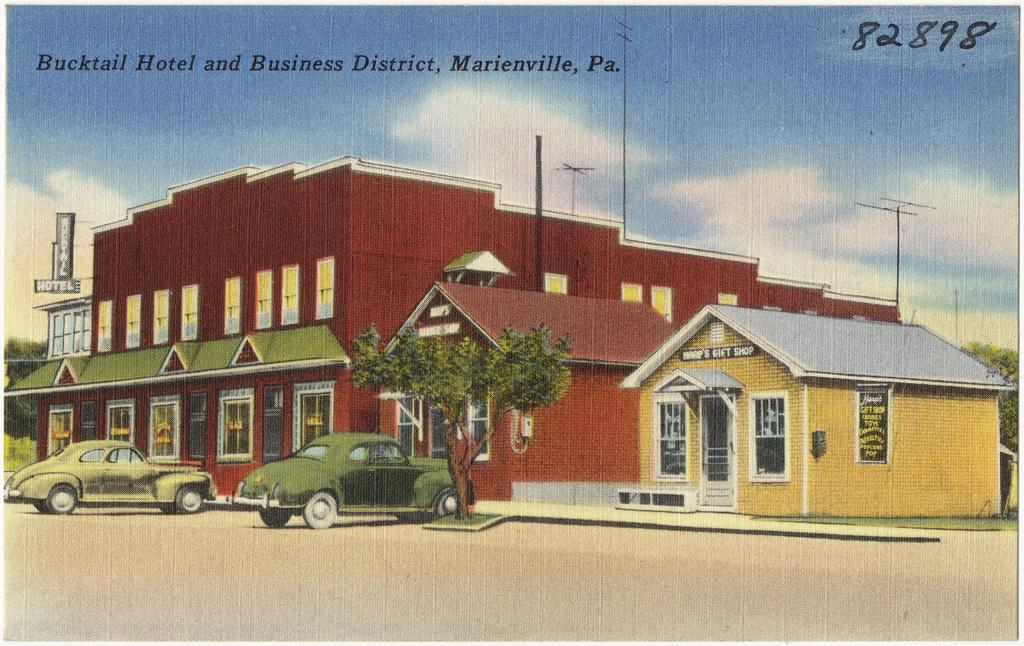What type of structure is visible in the image? There is a house and a building in the image. What mode of transportation can be seen in the image? Cars are depicted in the image. What is the medium of the image? The image is printed on paper. What type of vegetation is present in the image? There are trees and plants in the image. What can be seen in the sky in the image? There are clouds in the sky. What type of harmony is being played by the trees in the image? There is no indication of harmony being played by the trees in the image, as trees do not produce music. What type of shade is provided by the clouds in the image? The clouds in the image do not provide shade, as they are in the sky and not directly above any objects or people. 